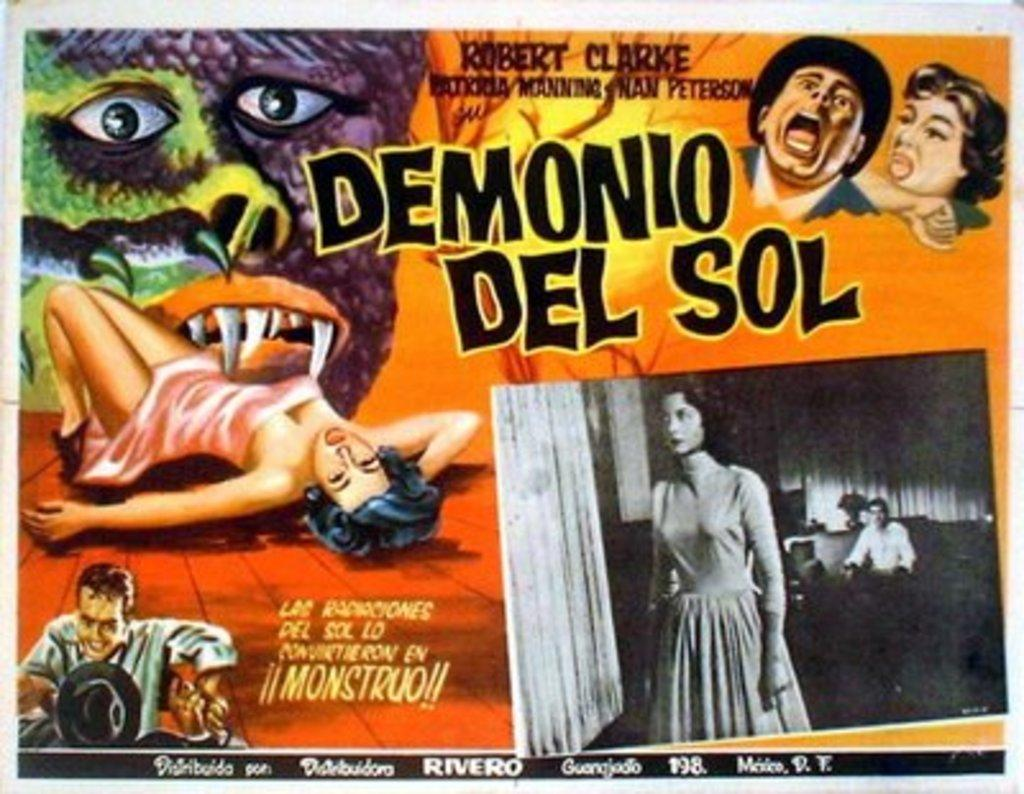<image>
Create a compact narrative representing the image presented. a poster that says 'demonio del sol' on it 